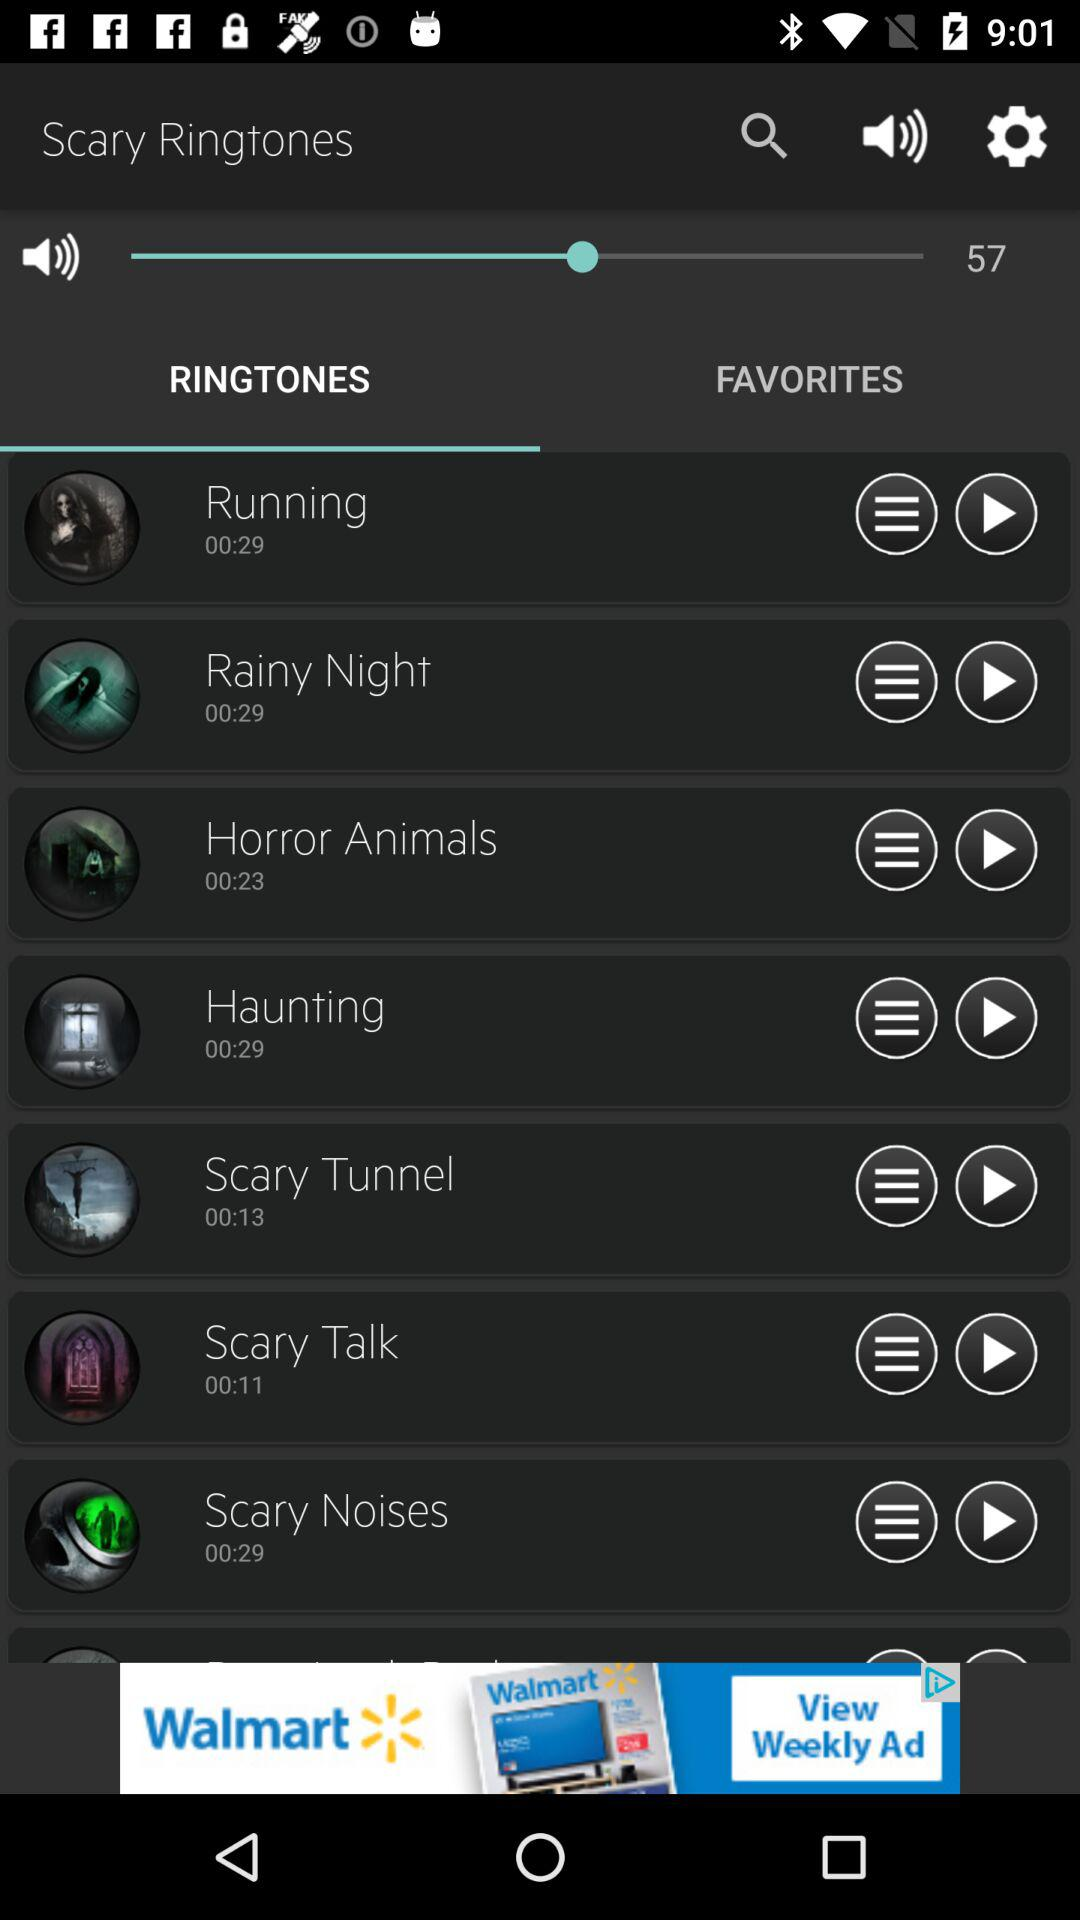What is the selected sound volume? The selected sound volume is 57. 